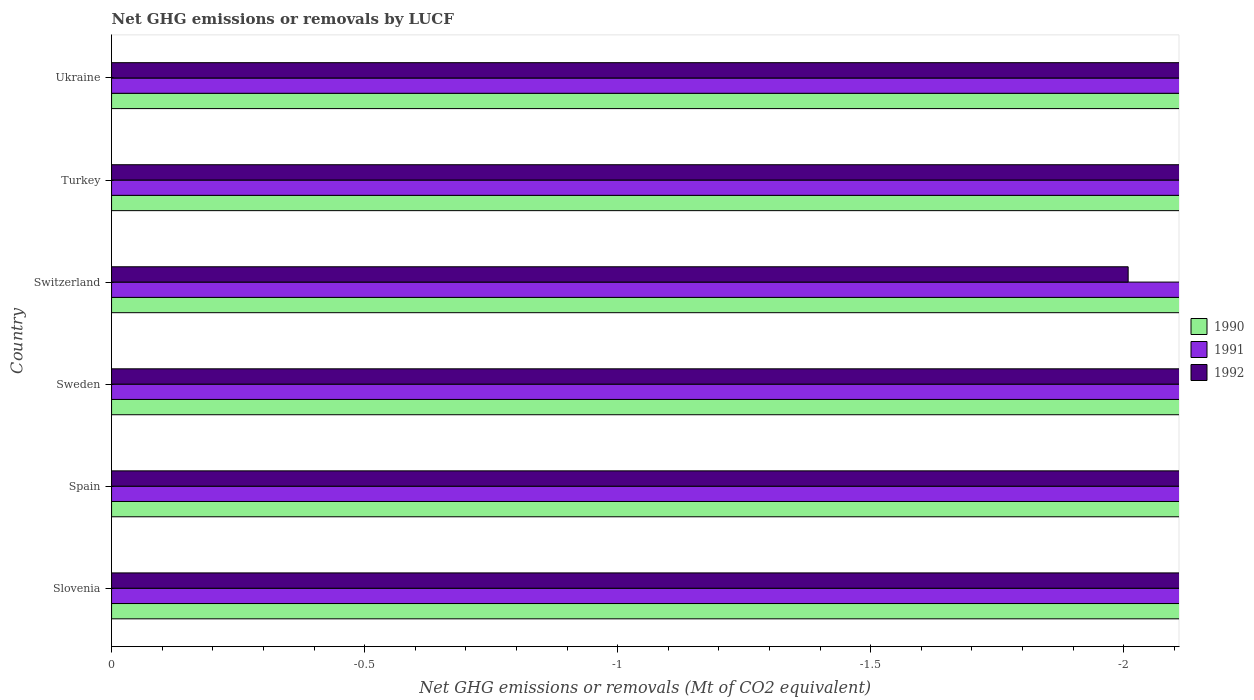How many bars are there on the 2nd tick from the bottom?
Offer a terse response. 0. What is the label of the 6th group of bars from the top?
Your answer should be very brief. Slovenia. What is the net GHG emissions or removals by LUCF in 1990 in Spain?
Offer a very short reply. 0. Across all countries, what is the minimum net GHG emissions or removals by LUCF in 1991?
Give a very brief answer. 0. What is the total net GHG emissions or removals by LUCF in 1990 in the graph?
Offer a very short reply. 0. What is the average net GHG emissions or removals by LUCF in 1991 per country?
Ensure brevity in your answer.  0. In how many countries, is the net GHG emissions or removals by LUCF in 1991 greater than -1.8 Mt?
Provide a succinct answer. 0. In how many countries, is the net GHG emissions or removals by LUCF in 1990 greater than the average net GHG emissions or removals by LUCF in 1990 taken over all countries?
Your response must be concise. 0. How many bars are there?
Ensure brevity in your answer.  0. Are all the bars in the graph horizontal?
Make the answer very short. Yes. Are the values on the major ticks of X-axis written in scientific E-notation?
Provide a short and direct response. No. Where does the legend appear in the graph?
Offer a very short reply. Center right. How many legend labels are there?
Offer a very short reply. 3. How are the legend labels stacked?
Ensure brevity in your answer.  Vertical. What is the title of the graph?
Your answer should be compact. Net GHG emissions or removals by LUCF. Does "2000" appear as one of the legend labels in the graph?
Provide a succinct answer. No. What is the label or title of the X-axis?
Your answer should be very brief. Net GHG emissions or removals (Mt of CO2 equivalent). What is the Net GHG emissions or removals (Mt of CO2 equivalent) of 1990 in Spain?
Provide a short and direct response. 0. What is the Net GHG emissions or removals (Mt of CO2 equivalent) in 1992 in Spain?
Provide a short and direct response. 0. What is the Net GHG emissions or removals (Mt of CO2 equivalent) in 1990 in Sweden?
Keep it short and to the point. 0. What is the Net GHG emissions or removals (Mt of CO2 equivalent) of 1992 in Sweden?
Offer a terse response. 0. What is the Net GHG emissions or removals (Mt of CO2 equivalent) of 1991 in Switzerland?
Your response must be concise. 0. What is the Net GHG emissions or removals (Mt of CO2 equivalent) in 1992 in Switzerland?
Provide a succinct answer. 0. What is the Net GHG emissions or removals (Mt of CO2 equivalent) of 1992 in Turkey?
Provide a short and direct response. 0. What is the Net GHG emissions or removals (Mt of CO2 equivalent) of 1991 in Ukraine?
Give a very brief answer. 0. What is the total Net GHG emissions or removals (Mt of CO2 equivalent) in 1991 in the graph?
Your answer should be very brief. 0. What is the average Net GHG emissions or removals (Mt of CO2 equivalent) in 1992 per country?
Keep it short and to the point. 0. 